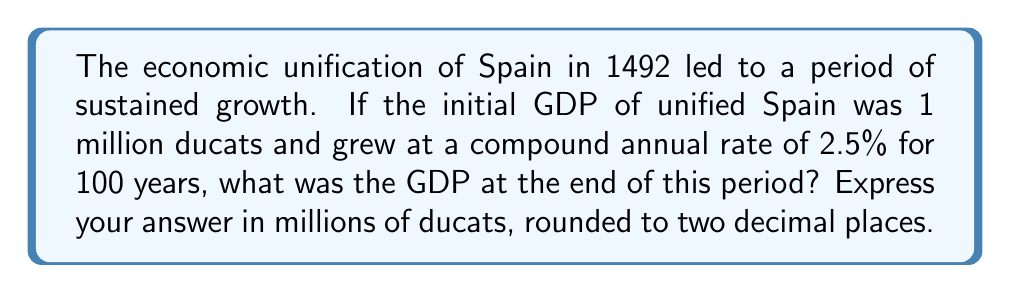Give your solution to this math problem. To solve this problem, we'll use the compound interest formula:

$$A = P(1 + r)^t$$

Where:
$A$ = Final amount
$P$ = Principal (initial amount)
$r$ = Annual interest rate (in decimal form)
$t$ = Time in years

Given:
$P = 1,000,000$ ducats
$r = 2.5\% = 0.025$
$t = 100$ years

Let's substitute these values into the formula:

$$A = 1,000,000(1 + 0.025)^{100}$$

Now, let's calculate:

1) First, compute $(1 + 0.025)^{100}$:
   $$(1.025)^{100} \approx 11.8137$$

2) Multiply this by the initial amount:
   $$1,000,000 \times 11.8137 = 11,813,700$$

3) Convert to millions and round to two decimal places:
   $$11,813,700 \div 1,000,000 \approx 11.81$$

Therefore, after 100 years, the GDP would be approximately 11.81 million ducats.
Answer: 11.81 million ducats 